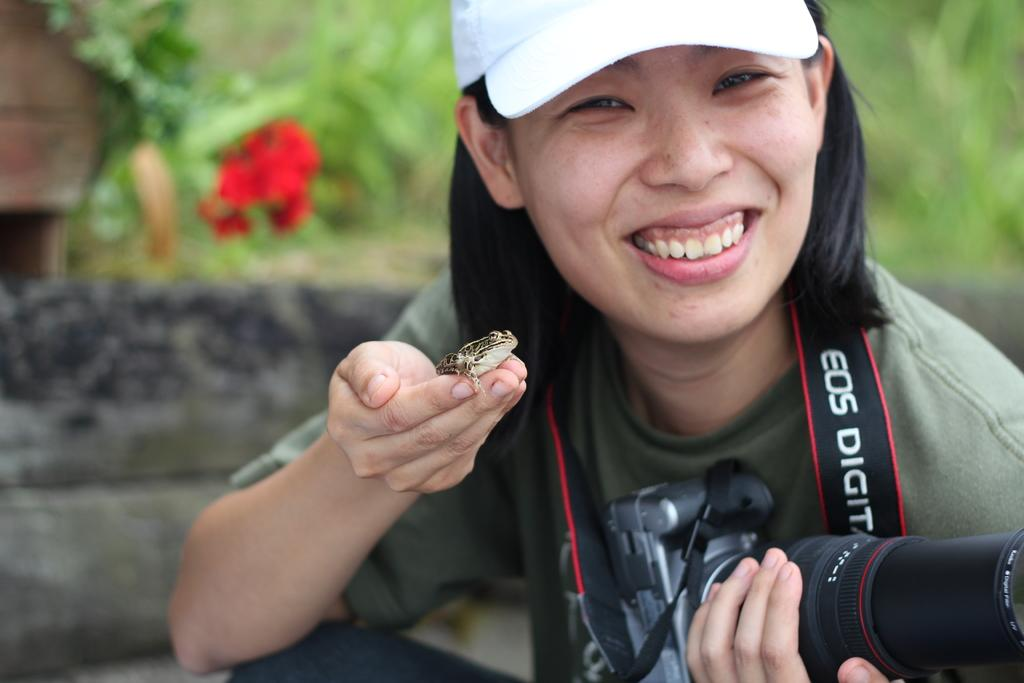Who is present in the image? There is a woman in the image. What is the woman doing in the image? The woman is smiling in the image. What is the woman wearing on her head? The woman is wearing a cap in the image. What object can be seen in the image related to photography? There is a camera in the image. What type of animal is on the woman's hand? There is a frog on the woman's hand in the image. What type of wilderness can be seen in the background of the image? There is no wilderness visible in the image; it is focused on the woman and the frog on her hand. Can you tell me how many bats are flying around the woman in the image? There are no bats present in the image. 